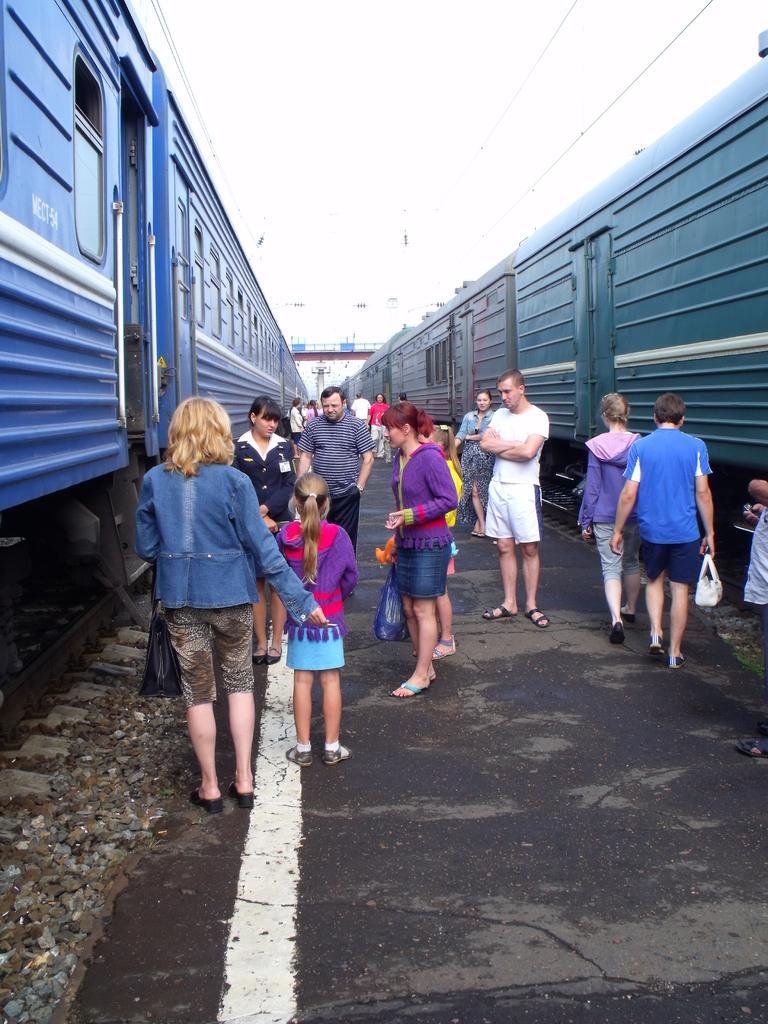In one or two sentences, can you explain what this image depicts? In the image we can see there are many people standing and some of them are walking, they are wearing clothes and some of them are wearing shoes and carrying bags. Here we can see trains, on the train tracks. Here we can see the road, stones, electric wires and the sky. 